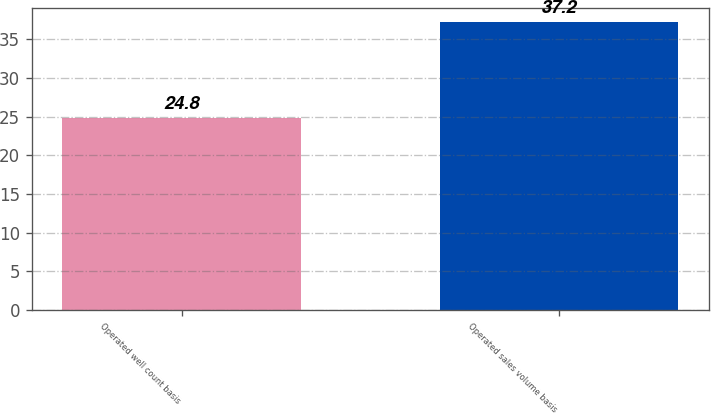<chart> <loc_0><loc_0><loc_500><loc_500><bar_chart><fcel>Operated well count basis<fcel>Operated sales volume basis<nl><fcel>24.8<fcel>37.2<nl></chart> 